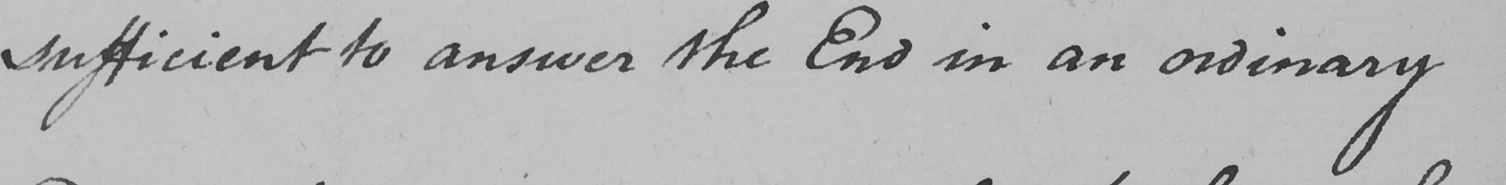Can you read and transcribe this handwriting? sufficient to answer the End in an ordinary 